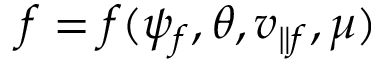Convert formula to latex. <formula><loc_0><loc_0><loc_500><loc_500>f = f ( \psi _ { f } , \theta , v _ { \| f } , \mu )</formula> 